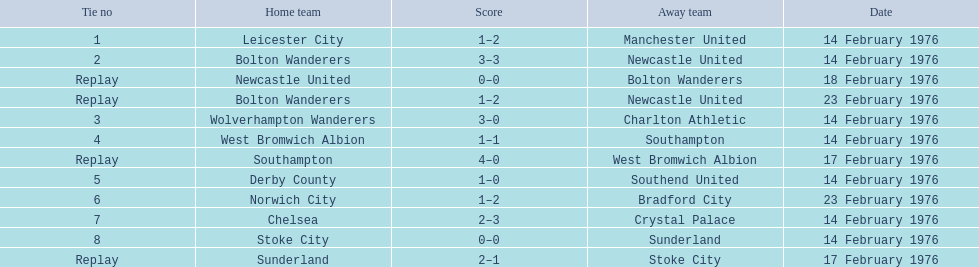What are all of the scores of the 1975-76 fa cup? 1–2, 3–3, 0–0, 1–2, 3–0, 1–1, 4–0, 1–0, 1–2, 2–3, 0–0, 2–1. What are the scores for manchester united or wolverhampton wanderers? 1–2, 3–0. Which has the highest score? 3–0. Who was this score for? Wolverhampton Wanderers. 